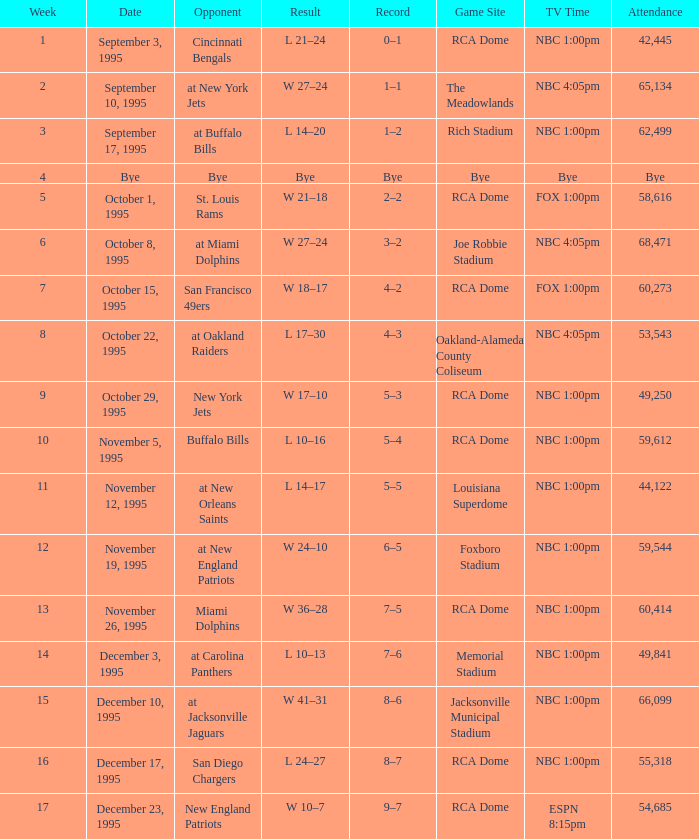What's the game location with a rival of san diego chargers? RCA Dome. 